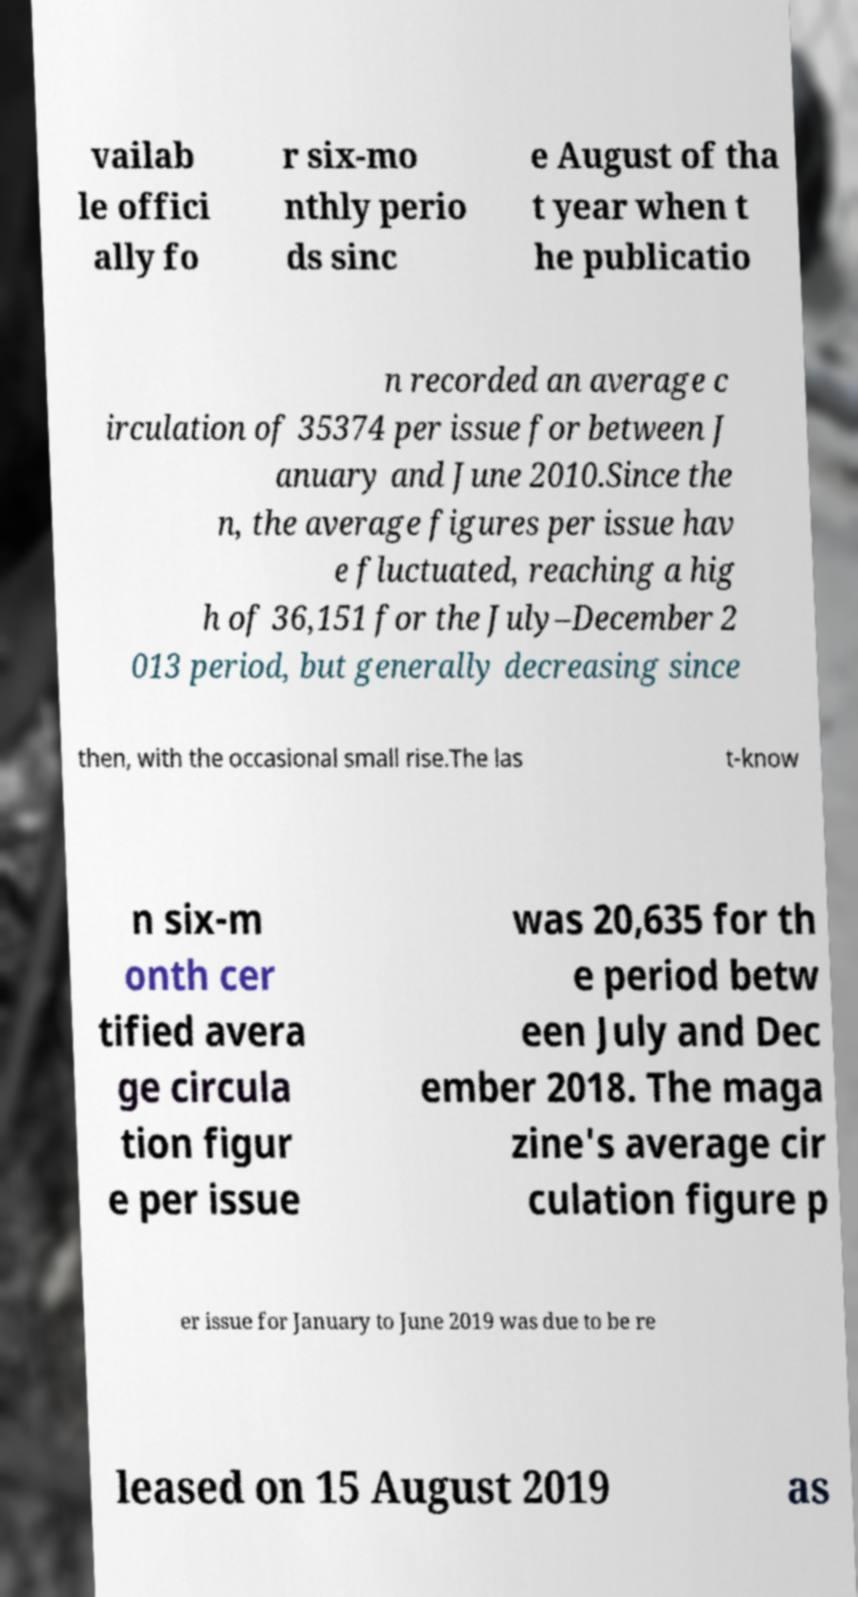Could you extract and type out the text from this image? vailab le offici ally fo r six-mo nthly perio ds sinc e August of tha t year when t he publicatio n recorded an average c irculation of 35374 per issue for between J anuary and June 2010.Since the n, the average figures per issue hav e fluctuated, reaching a hig h of 36,151 for the July–December 2 013 period, but generally decreasing since then, with the occasional small rise.The las t-know n six-m onth cer tified avera ge circula tion figur e per issue was 20,635 for th e period betw een July and Dec ember 2018. The maga zine's average cir culation figure p er issue for January to June 2019 was due to be re leased on 15 August 2019 as 